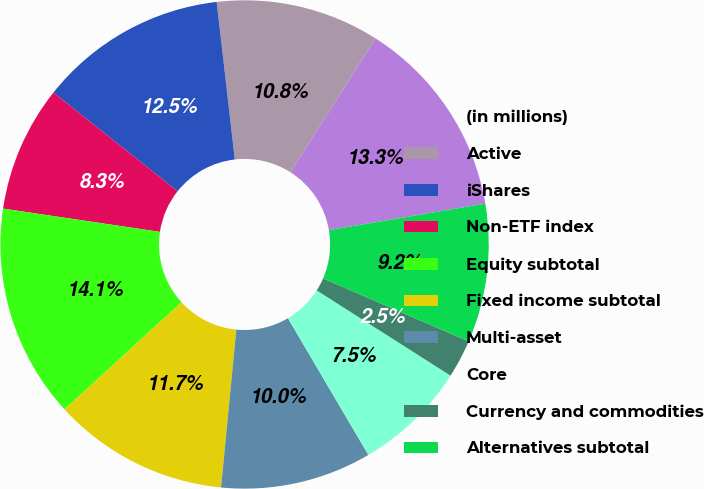Convert chart to OTSL. <chart><loc_0><loc_0><loc_500><loc_500><pie_chart><fcel>(in millions)<fcel>Active<fcel>iShares<fcel>Non-ETF index<fcel>Equity subtotal<fcel>Fixed income subtotal<fcel>Multi-asset<fcel>Core<fcel>Currency and commodities<fcel>Alternatives subtotal<nl><fcel>13.32%<fcel>10.83%<fcel>12.49%<fcel>8.34%<fcel>14.15%<fcel>11.66%<fcel>10.0%<fcel>7.51%<fcel>2.53%<fcel>9.17%<nl></chart> 